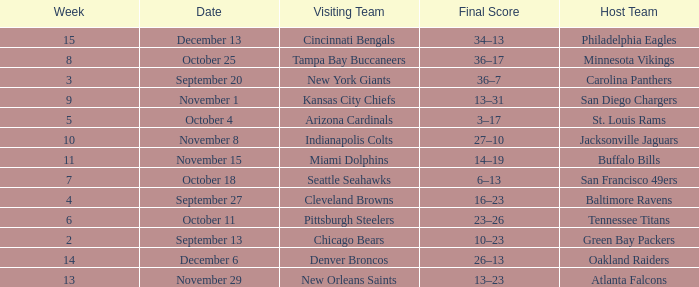When did the Baltimore Ravens play at home ? September 27. 